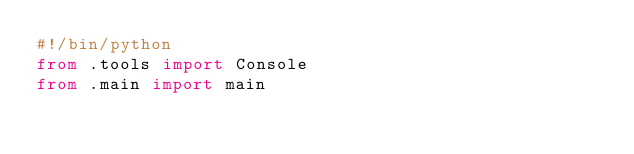Convert code to text. <code><loc_0><loc_0><loc_500><loc_500><_Python_>#!/bin/python
from .tools import Console
from .main import main
</code> 